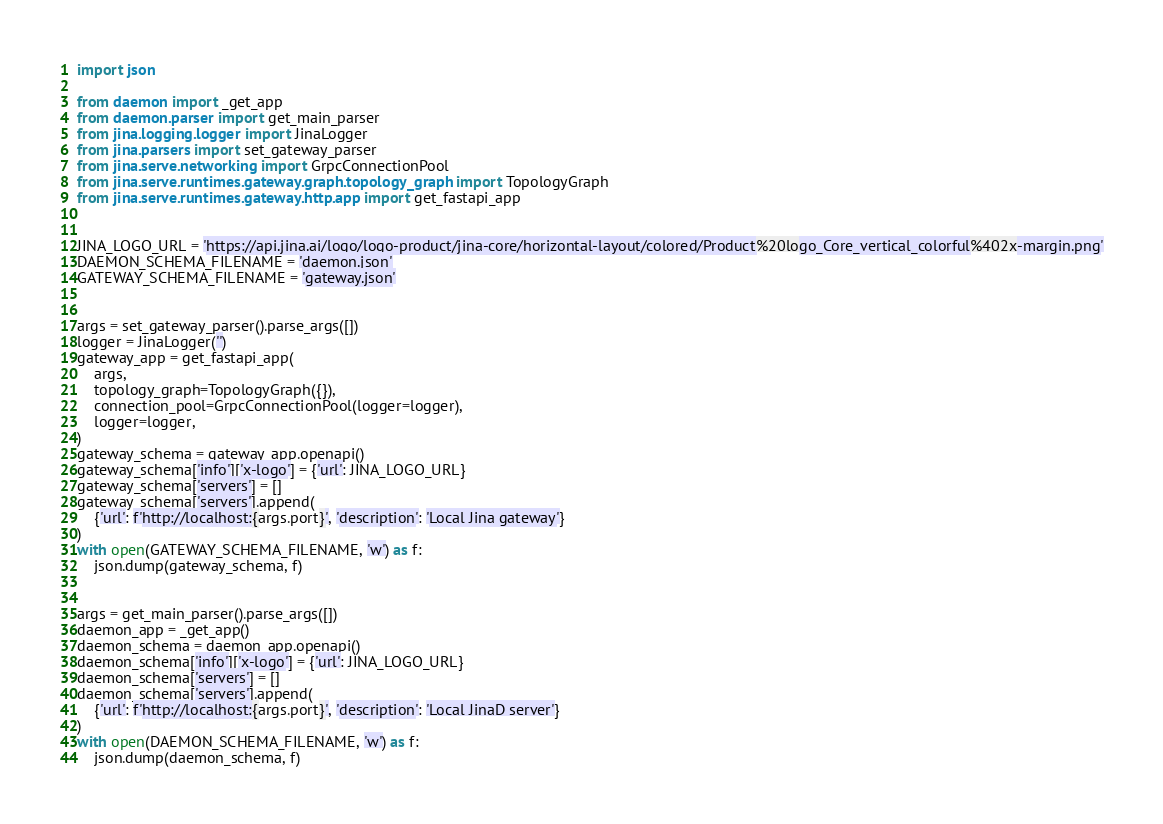<code> <loc_0><loc_0><loc_500><loc_500><_Python_>import json

from daemon import _get_app
from daemon.parser import get_main_parser
from jina.logging.logger import JinaLogger
from jina.parsers import set_gateway_parser
from jina.serve.networking import GrpcConnectionPool
from jina.serve.runtimes.gateway.graph.topology_graph import TopologyGraph
from jina.serve.runtimes.gateway.http.app import get_fastapi_app


JINA_LOGO_URL = 'https://api.jina.ai/logo/logo-product/jina-core/horizontal-layout/colored/Product%20logo_Core_vertical_colorful%402x-margin.png'
DAEMON_SCHEMA_FILENAME = 'daemon.json'
GATEWAY_SCHEMA_FILENAME = 'gateway.json'


args = set_gateway_parser().parse_args([])
logger = JinaLogger('')
gateway_app = get_fastapi_app(
    args,
    topology_graph=TopologyGraph({}),
    connection_pool=GrpcConnectionPool(logger=logger),
    logger=logger,
)
gateway_schema = gateway_app.openapi()
gateway_schema['info']['x-logo'] = {'url': JINA_LOGO_URL}
gateway_schema['servers'] = []
gateway_schema['servers'].append(
    {'url': f'http://localhost:{args.port}', 'description': 'Local Jina gateway'}
)
with open(GATEWAY_SCHEMA_FILENAME, 'w') as f:
    json.dump(gateway_schema, f)


args = get_main_parser().parse_args([])
daemon_app = _get_app()
daemon_schema = daemon_app.openapi()
daemon_schema['info']['x-logo'] = {'url': JINA_LOGO_URL}
daemon_schema['servers'] = []
daemon_schema['servers'].append(
    {'url': f'http://localhost:{args.port}', 'description': 'Local JinaD server'}
)
with open(DAEMON_SCHEMA_FILENAME, 'w') as f:
    json.dump(daemon_schema, f)
</code> 